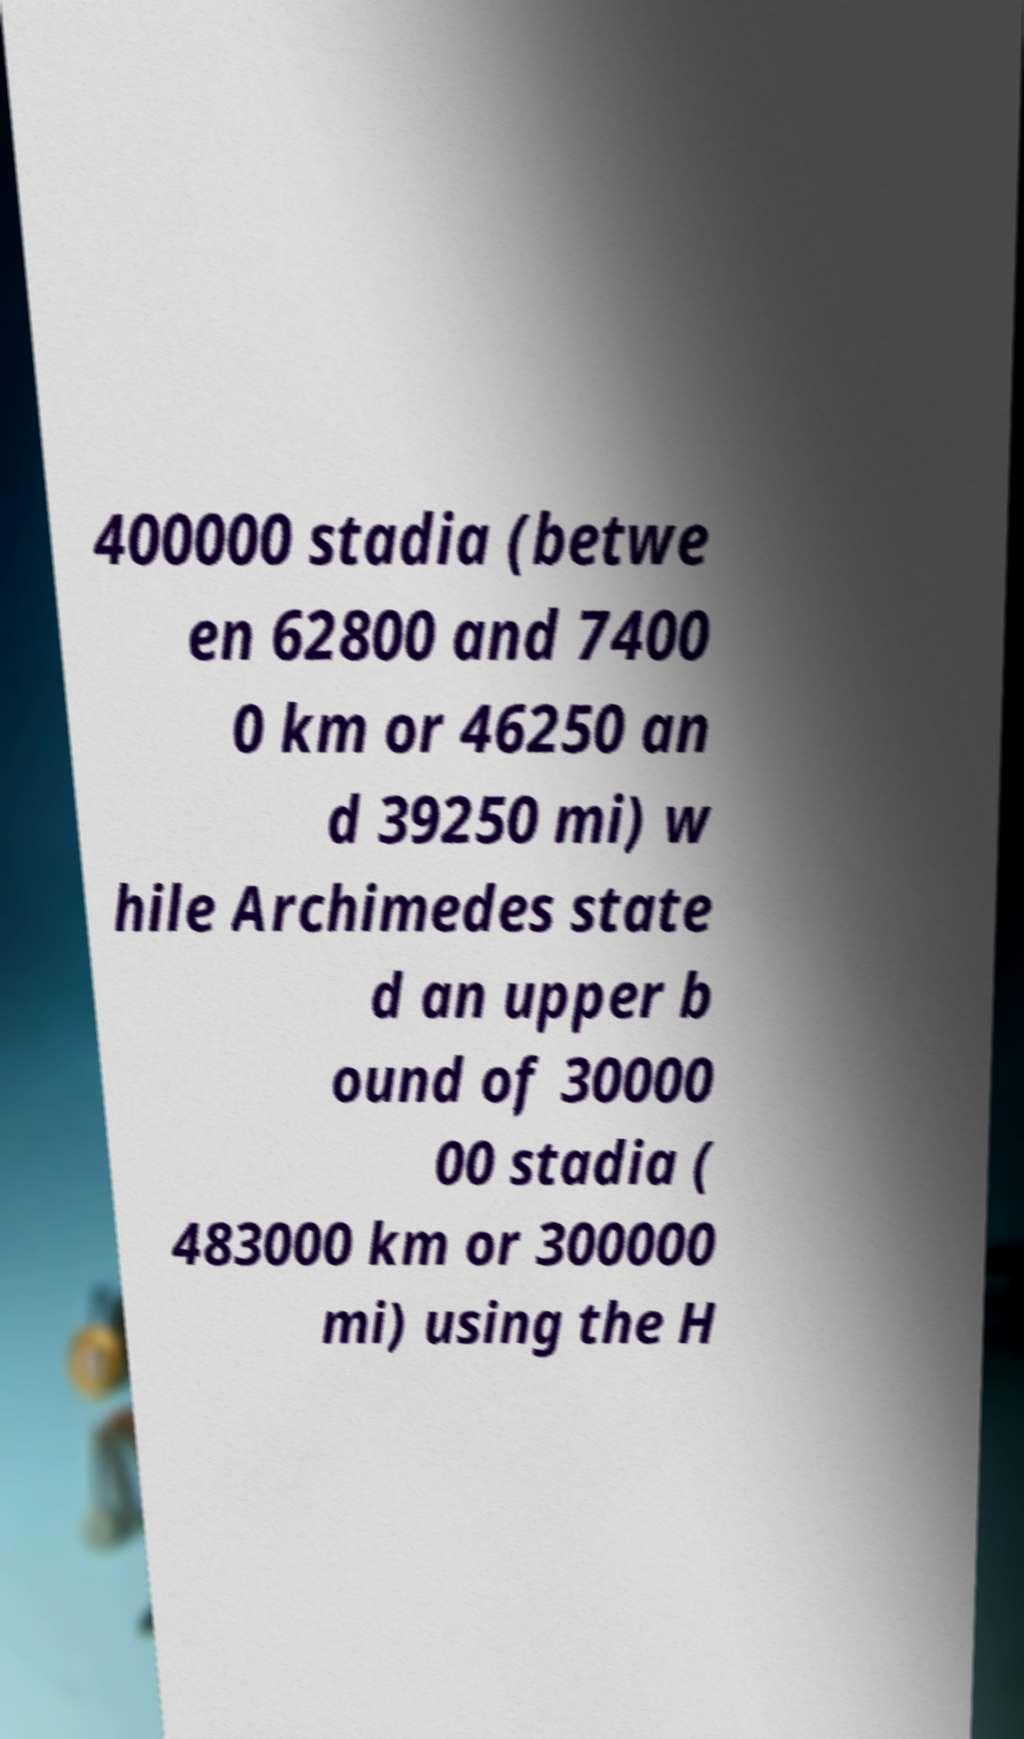Please identify and transcribe the text found in this image. 400000 stadia (betwe en 62800 and 7400 0 km or 46250 an d 39250 mi) w hile Archimedes state d an upper b ound of 30000 00 stadia ( 483000 km or 300000 mi) using the H 